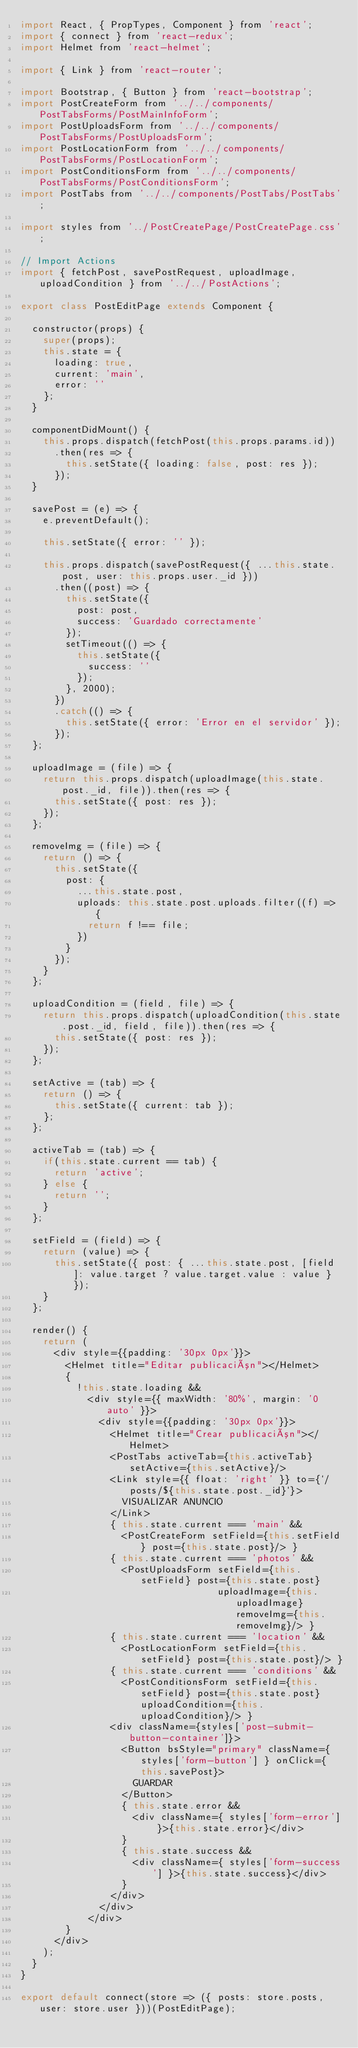Convert code to text. <code><loc_0><loc_0><loc_500><loc_500><_JavaScript_>import React, { PropTypes, Component } from 'react';
import { connect } from 'react-redux';
import Helmet from 'react-helmet';

import { Link } from 'react-router';

import Bootstrap, { Button } from 'react-bootstrap';
import PostCreateForm from '../../components/PostTabsForms/PostMainInfoForm';
import PostUploadsForm from '../../components/PostTabsForms/PostUploadsForm';
import PostLocationForm from '../../components/PostTabsForms/PostLocationForm';
import PostConditionsForm from '../../components/PostTabsForms/PostConditionsForm';
import PostTabs from '../../components/PostTabs/PostTabs';

import styles from '../PostCreatePage/PostCreatePage.css';

// Import Actions
import { fetchPost, savePostRequest, uploadImage, uploadCondition } from '../../PostActions';

export class PostEditPage extends Component {

  constructor(props) {
    super(props);
    this.state = {
      loading: true,
      current: 'main',
      error: ''
    };
  }

  componentDidMount() {
    this.props.dispatch(fetchPost(this.props.params.id))
      .then(res => {
        this.setState({ loading: false, post: res });
      });
  }

  savePost = (e) => {
    e.preventDefault();

    this.setState({ error: '' });

    this.props.dispatch(savePostRequest({ ...this.state.post, user: this.props.user._id }))
      .then((post) => {
        this.setState({
          post: post,
          success: 'Guardado correctamente'
        });
        setTimeout(() => {
          this.setState({
            success: ''
          });
        }, 2000);
      })
      .catch(() => {
        this.setState({ error: 'Error en el servidor' });
      });
  };

  uploadImage = (file) => {
    return this.props.dispatch(uploadImage(this.state.post._id, file)).then(res => {
      this.setState({ post: res });
    });
  };

  removeImg = (file) => {
    return () => {
      this.setState({
        post: {
          ...this.state.post,
          uploads: this.state.post.uploads.filter((f) => {
            return f !== file;
          })
        }
      });
    }
  };

  uploadCondition = (field, file) => {
    return this.props.dispatch(uploadCondition(this.state.post._id, field, file)).then(res => {
      this.setState({ post: res });
    });
  };

  setActive = (tab) => {
    return () => {
      this.setState({ current: tab });
    };
  };

  activeTab = (tab) => {
    if(this.state.current == tab) {
      return 'active';
    } else {
      return '';
    }
  };

  setField = (field) => {
    return (value) => {
      this.setState({ post: { ...this.state.post, [field]: value.target ? value.target.value : value } });
    }
  };

  render() {
    return (
      <div style={{padding: '30px 0px'}}>
        <Helmet title="Editar publicación"></Helmet>
        {
          !this.state.loading &&
            <div style={{ maxWidth: '80%', margin: '0 auto' }}>
              <div style={{padding: '30px 0px'}}>
                <Helmet title="Crear publicación"></Helmet>
                <PostTabs activeTab={this.activeTab} setActive={this.setActive}/>
                <Link style={{ float: 'right' }} to={`/posts/${this.state.post._id}`}>
                  VISUALIZAR ANUNCIO
                </Link>
                { this.state.current === 'main' &&
                  <PostCreateForm setField={this.setField} post={this.state.post}/> }
                { this.state.current === 'photos' &&
                  <PostUploadsForm setField={this.setField} post={this.state.post}
                                   uploadImage={this.uploadImage} removeImg={this.removeImg}/> }
                { this.state.current === 'location' &&
                  <PostLocationForm setField={this.setField} post={this.state.post}/> }
                { this.state.current === 'conditions' &&
                  <PostConditionsForm setField={this.setField} post={this.state.post} uploadCondition={this.uploadCondition}/> }
                <div className={styles['post-submit-button-container']}>
                  <Button bsStyle="primary" className={ styles['form-button'] } onClick={this.savePost}>
                    GUARDAR
                  </Button>
                  { this.state.error &&
                    <div className={ styles['form-error'] }>{this.state.error}</div>
                  }
                  { this.state.success &&
                    <div className={ styles['form-success'] }>{this.state.success}</div>
                  }
                </div>
              </div>
            </div>
        }
      </div>
    );
  }
}

export default connect(store => ({ posts: store.posts, user: store.user }))(PostEditPage);
</code> 